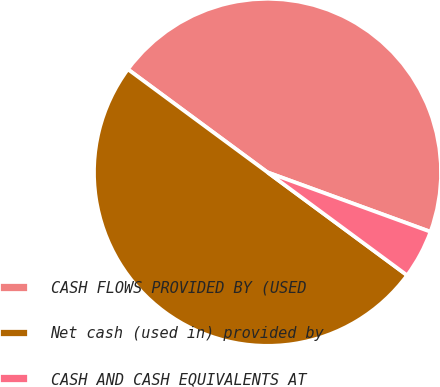Convert chart. <chart><loc_0><loc_0><loc_500><loc_500><pie_chart><fcel>CASH FLOWS PROVIDED BY (USED<fcel>Net cash (used in) provided by<fcel>CASH AND CASH EQUIVALENTS AT<nl><fcel>45.45%<fcel>50.0%<fcel>4.55%<nl></chart> 